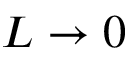Convert formula to latex. <formula><loc_0><loc_0><loc_500><loc_500>L \rightarrow 0</formula> 